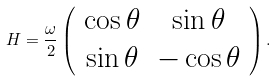Convert formula to latex. <formula><loc_0><loc_0><loc_500><loc_500>H = \frac { \omega } { 2 } \left ( \begin{array} { c c } \cos \theta & \sin \theta \\ \sin \theta & - \cos \theta \\ \end{array} \right ) .</formula> 